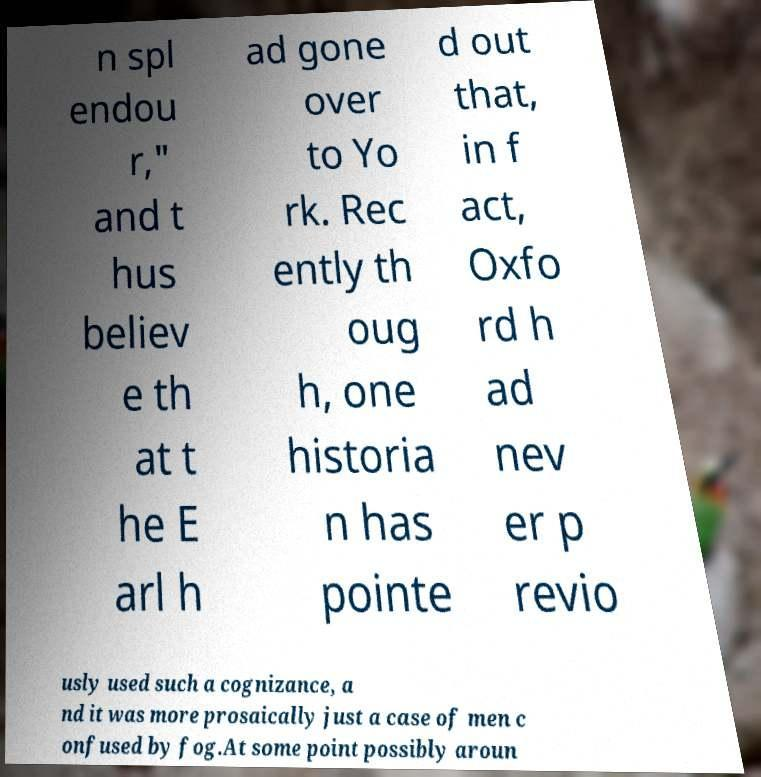Please read and relay the text visible in this image. What does it say? n spl endou r," and t hus believ e th at t he E arl h ad gone over to Yo rk. Rec ently th oug h, one historia n has pointe d out that, in f act, Oxfo rd h ad nev er p revio usly used such a cognizance, a nd it was more prosaically just a case of men c onfused by fog.At some point possibly aroun 